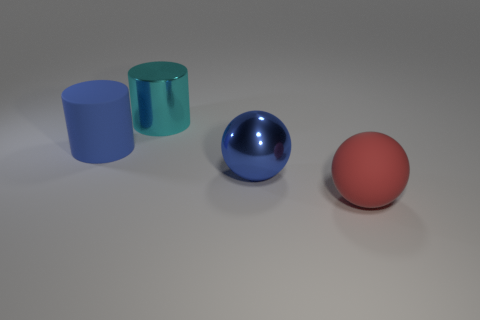Add 4 purple matte cylinders. How many objects exist? 8 Add 2 cylinders. How many cylinders are left? 4 Add 2 blue matte cylinders. How many blue matte cylinders exist? 3 Subtract 1 blue spheres. How many objects are left? 3 Subtract all tiny shiny blocks. Subtract all red rubber objects. How many objects are left? 3 